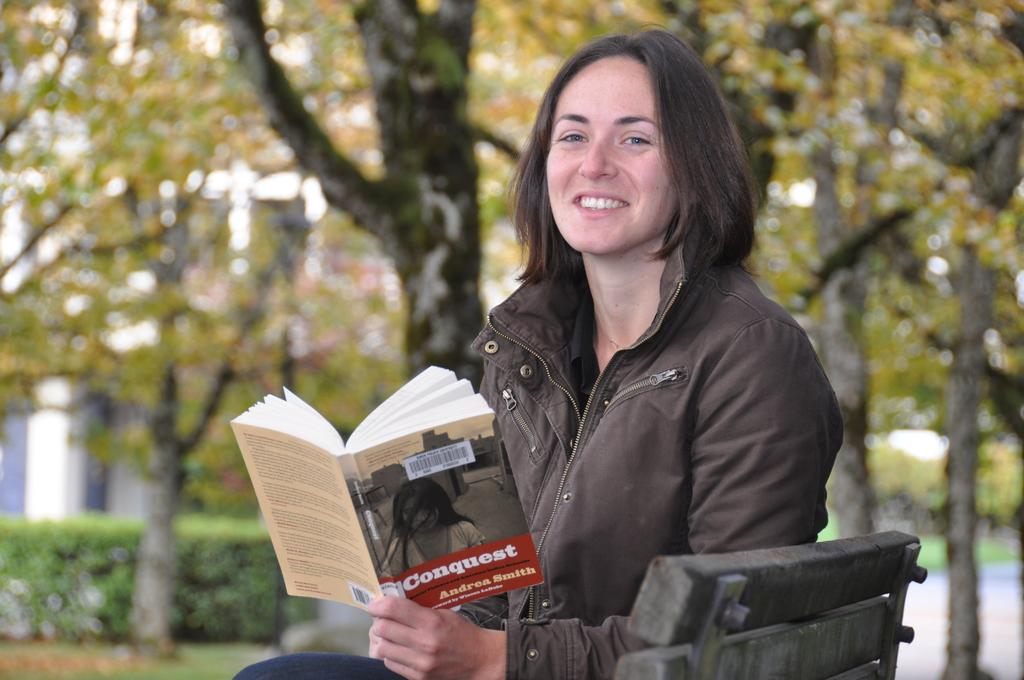Provide a one-sentence caption for the provided image. A woman reads a thin library paperback which is titled Conquest. 